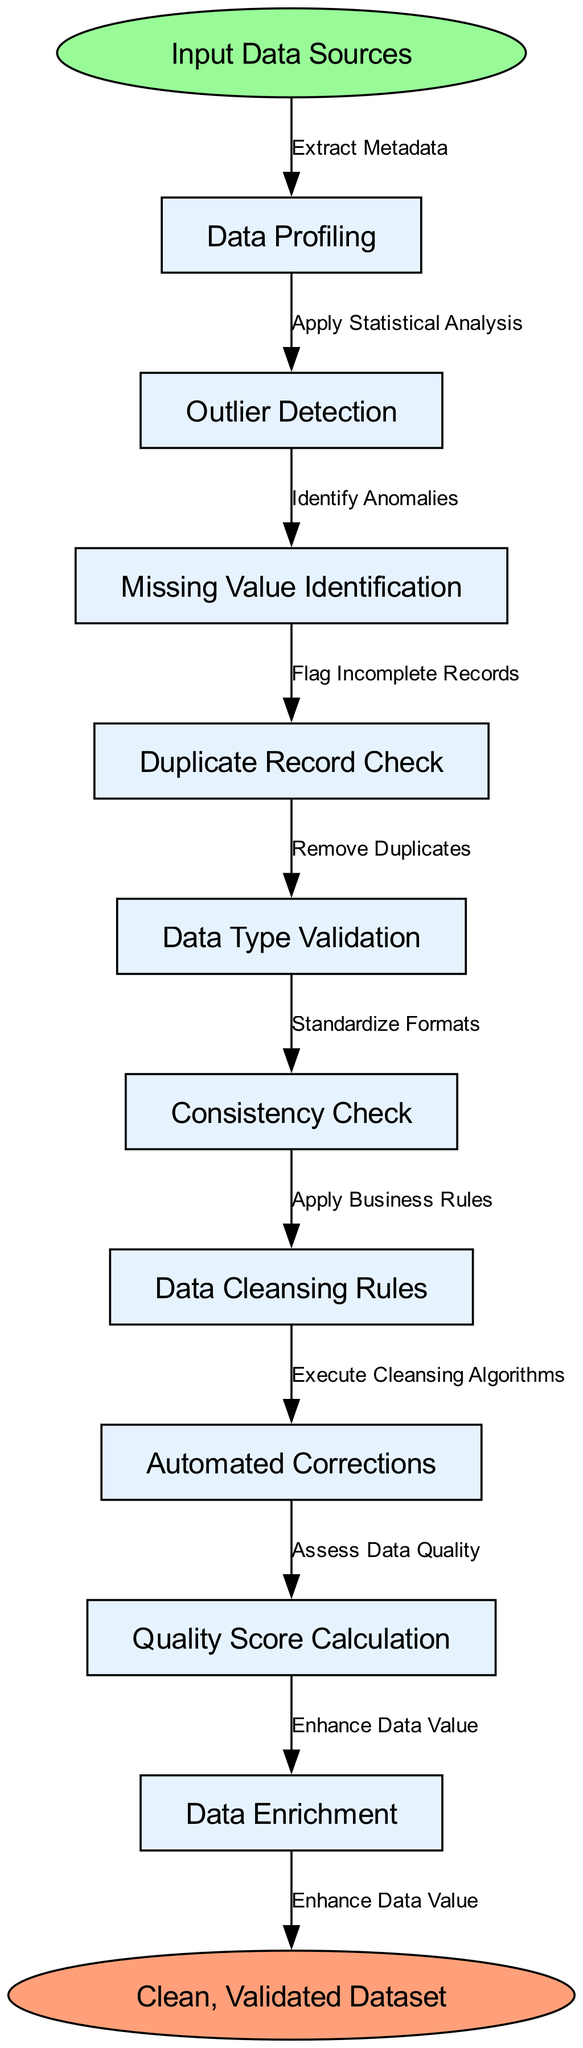What is the starting point of the flow chart? The starting point is clearly labeled as "Input Data Sources," which is depicted at the top of the flow chart, indicating where the process begins.
Answer: Input Data Sources How many nodes are there in total? The diagram lists a total of ten process nodes, starting from "Data Profiling" through "Data Enrichment," in addition to the start and end points, resulting in twelve nodes overall.
Answer: Twelve What is the last process before reaching the end? The last node before the end point is "Data Enrichment," which is connected to the end node, signaling the final step in the data quality assessment process.
Answer: Data Enrichment Which process involves checking for duplicates? The process labeled "Duplicate Record Check" specifically focuses on identifying and removing duplicate entries from the dataset during the cleansing process.
Answer: Duplicate Record Check What is the connection between "Missing Value Identification" and the end node? "Missing Value Identification" leads to "Data Cleansing Rules," which subsequently connects to "Automated Corrections" before reaching the end node, indicating a sequential step in managing incomplete data.
Answer: Automated Corrections Explain the flow from "Outlier Detection" to the end node. The flow starts at "Outlier Detection," which involves "Identify Anomalies." Following this, the process moves to "Missing Value Identification," then to "Data Cleansing Rules," continuing to "Automated Corrections" before finally arriving at the end, ensuring that detected issues are addressed.
Answer: Automated Corrections What happens after "Data Profiling"? After "Data Profiling," the flow moves to "Outlier Detection," indicating that statistical summaries gathered during profiling lead to an examination for outliers in the data.
Answer: Outlier Detection How many edges connect the nodes in the diagram? There are eleven connections (or edges) as the flow of processes starts from "Input Data Sources" and traverses through ten nodes to reach the "Clean, Validated Dataset" end point.
Answer: Eleven 